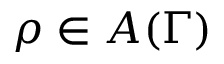Convert formula to latex. <formula><loc_0><loc_0><loc_500><loc_500>\rho \in A ( \Gamma )</formula> 